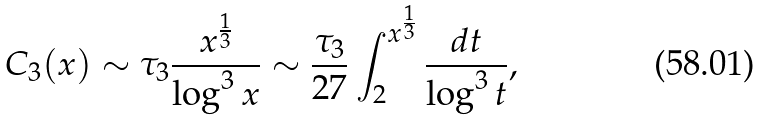<formula> <loc_0><loc_0><loc_500><loc_500>C _ { 3 } ( x ) \sim { \tau _ { 3 } } \frac { x ^ { \frac { 1 } { 3 } } } { \log ^ { 3 } x } \sim \frac { \tau _ { 3 } } { 2 7 } \int _ { 2 } ^ { x ^ { \frac { 1 } { 3 } } } \frac { d t } { \log ^ { 3 } t } ,</formula> 